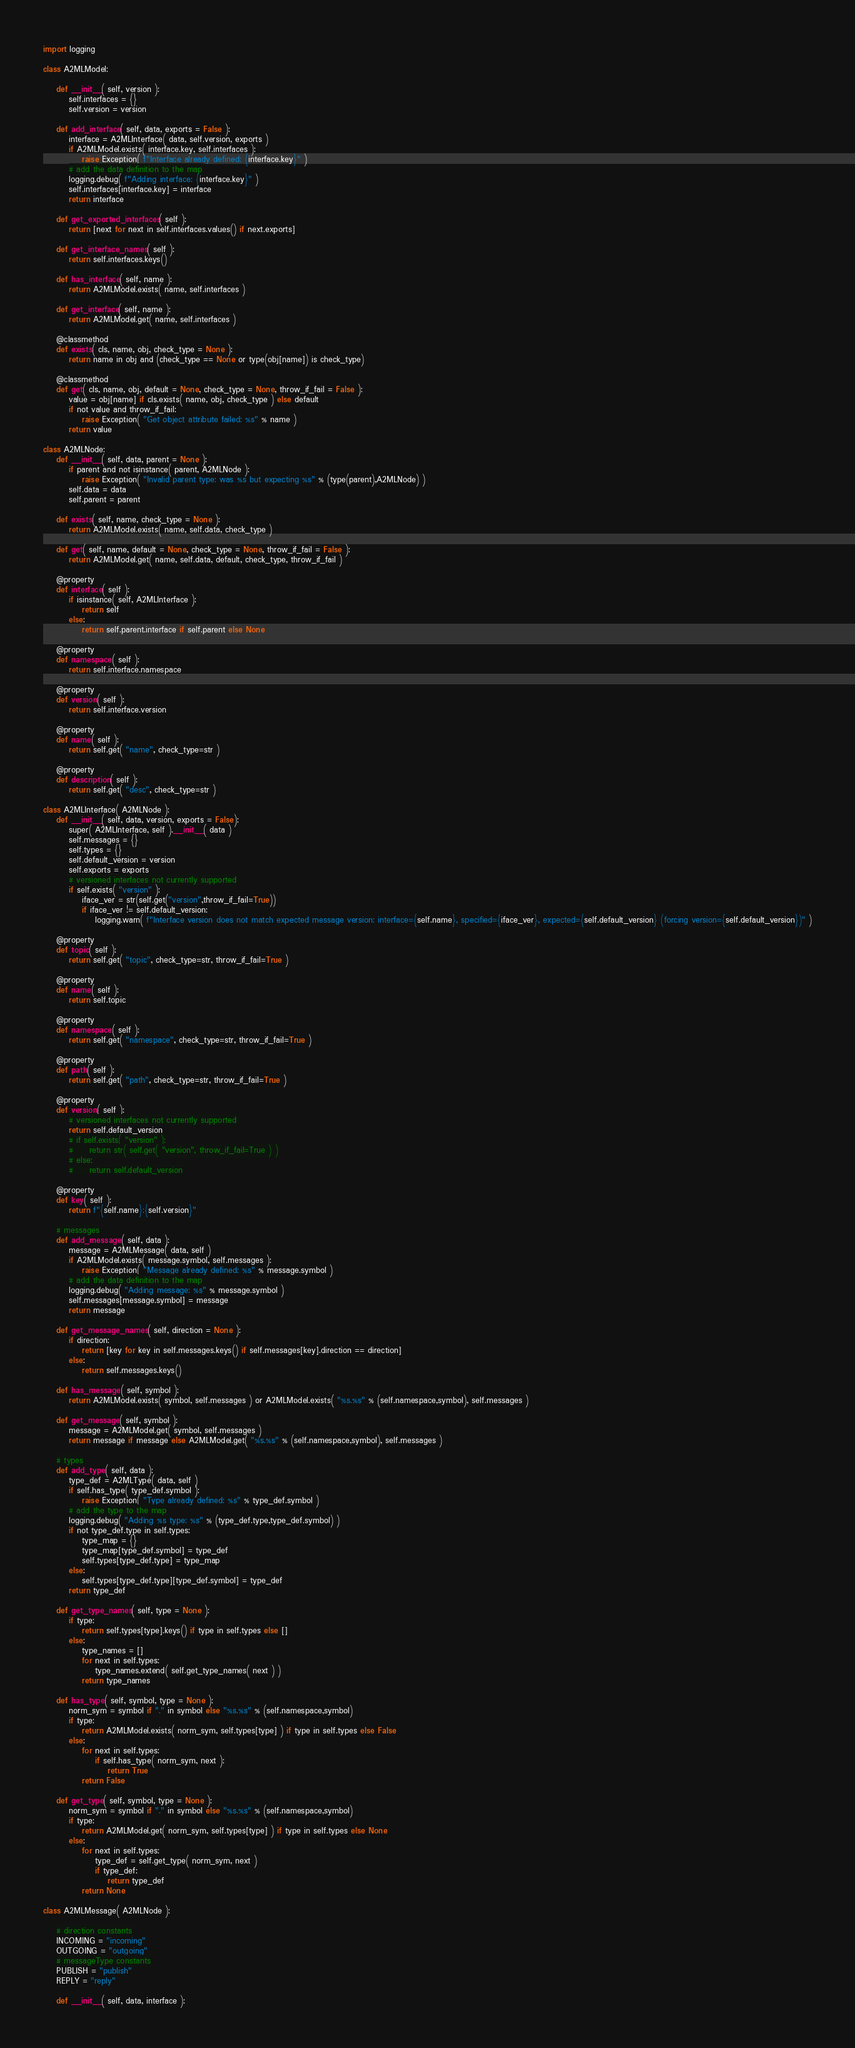<code> <loc_0><loc_0><loc_500><loc_500><_Python_>import logging

class A2MLModel:

    def __init__( self, version ):
        self.interfaces = {}
        self.version = version

    def add_interface( self, data, exports = False ):
        interface = A2MLInterface( data, self.version, exports )
        if A2MLModel.exists( interface.key, self.interfaces ):
            raise Exception( f"Interface already defined: {interface.key}" )
        # add the data definition to the map
        logging.debug( f"Adding interface: {interface.key}" )
        self.interfaces[interface.key] = interface
        return interface

    def get_exported_interfaces( self ):
        return [next for next in self.interfaces.values() if next.exports]

    def get_interface_names( self ):
        return self.interfaces.keys()

    def has_interface( self, name ):
        return A2MLModel.exists( name, self.interfaces )

    def get_interface( self, name ):
        return A2MLModel.get( name, self.interfaces )

    @classmethod
    def exists( cls, name, obj, check_type = None ):
        return name in obj and (check_type == None or type(obj[name]) is check_type)

    @classmethod
    def get( cls, name, obj, default = None, check_type = None, throw_if_fail = False ):
        value = obj[name] if cls.exists( name, obj, check_type ) else default
        if not value and throw_if_fail:
            raise Exception( "Get object attribute failed: %s" % name )
        return value

class A2MLNode:
    def __init__( self, data, parent = None ):
        if parent and not isinstance( parent, A2MLNode ):
            raise Exception( "Invalid parent type: was %s but expecting %s" % (type(parent),A2MLNode) )
        self.data = data
        self.parent = parent

    def exists( self, name, check_type = None ):
        return A2MLModel.exists( name, self.data, check_type )

    def get( self, name, default = None, check_type = None, throw_if_fail = False ):
        return A2MLModel.get( name, self.data, default, check_type, throw_if_fail )

    @property
    def interface( self ):
        if isinstance( self, A2MLInterface ):
            return self
        else:
            return self.parent.interface if self.parent else None

    @property
    def namespace( self ):
        return self.interface.namespace

    @property
    def version( self ):
        return self.interface.version

    @property 
    def name( self ):
        return self.get( "name", check_type=str )

    @property 
    def description( self ):
        return self.get( "desc", check_type=str )

class A2MLInterface( A2MLNode ):
    def __init__( self, data, version, exports = False):
        super( A2MLInterface, self ).__init__( data )
        self.messages = {}
        self.types = {}
        self.default_version = version
        self.exports = exports
        # versioned interfaces not currently supported
        if self.exists( "version" ):
            iface_ver = str(self.get("version",throw_if_fail=True))
            if iface_ver != self.default_version:
                logging.warn( f"Interface version does not match expected message version: interface={self.name}, specified={iface_ver}, expected={self.default_version} (forcing version={self.default_version})" )

    @property
    def topic( self ):
        return self.get( "topic", check_type=str, throw_if_fail=True )

    @property
    def name( self ):
        return self.topic

    @property
    def namespace( self ):
        return self.get( "namespace", check_type=str, throw_if_fail=True )

    @property
    def path( self ):
        return self.get( "path", check_type=str, throw_if_fail=True )

    @property
    def version( self ):
        # versioned interfaces not currently supported
        return self.default_version
        # if self.exists( "version" ):
        #     return str( self.get( "version", throw_if_fail=True ) )
        # else:
        #     return self.default_version

    @property
    def key( self ):
        return f"{self.name}:{self.version}"

    # messages
    def add_message( self, data ):
        message = A2MLMessage( data, self )
        if A2MLModel.exists( message.symbol, self.messages ):
            raise Exception( "Message already defined: %s" % message.symbol )
        # add the data definition to the map
        logging.debug( "Adding message: %s" % message.symbol )
        self.messages[message.symbol] = message
        return message

    def get_message_names( self, direction = None ):
        if direction:
            return [key for key in self.messages.keys() if self.messages[key].direction == direction]
        else:
            return self.messages.keys()

    def has_message( self, symbol ):
        return A2MLModel.exists( symbol, self.messages ) or A2MLModel.exists( "%s.%s" % (self.namespace,symbol), self.messages )

    def get_message( self, symbol ):
        message = A2MLModel.get( symbol, self.messages )
        return message if message else A2MLModel.get( "%s.%s" % (self.namespace,symbol), self.messages )

    # types
    def add_type( self, data ):
        type_def = A2MLType( data, self )
        if self.has_type( type_def.symbol ):
            raise Exception( "Type already defined: %s" % type_def.symbol )
        # add the type to the map
        logging.debug( "Adding %s type: %s" % (type_def.type,type_def.symbol) )
        if not type_def.type in self.types:
            type_map = {}
            type_map[type_def.symbol] = type_def
            self.types[type_def.type] = type_map
        else:
            self.types[type_def.type][type_def.symbol] = type_def
        return type_def

    def get_type_names( self, type = None ):
        if type:
            return self.types[type].keys() if type in self.types else []
        else:
            type_names = []
            for next in self.types:
                type_names.extend( self.get_type_names( next ) )
            return type_names

    def has_type( self, symbol, type = None ):
        norm_sym = symbol if "." in symbol else "%s.%s" % (self.namespace,symbol)
        if type:
            return A2MLModel.exists( norm_sym, self.types[type] ) if type in self.types else False
        else:
            for next in self.types:
                if self.has_type( norm_sym, next ):
                    return True
            return False

    def get_type( self, symbol, type = None ):
        norm_sym = symbol if "." in symbol else "%s.%s" % (self.namespace,symbol)
        if type:
            return A2MLModel.get( norm_sym, self.types[type] ) if type in self.types else None
        else:
            for next in self.types:
                type_def = self.get_type( norm_sym, next )
                if type_def:
                    return type_def
            return None
        
class A2MLMessage( A2MLNode ):

    # direction constants
    INCOMING = "incoming"
    OUTGOING = "outgoing"
    # messageType constants
    PUBLISH = "publish"
    REPLY = "reply"

    def __init__( self, data, interface ):</code> 